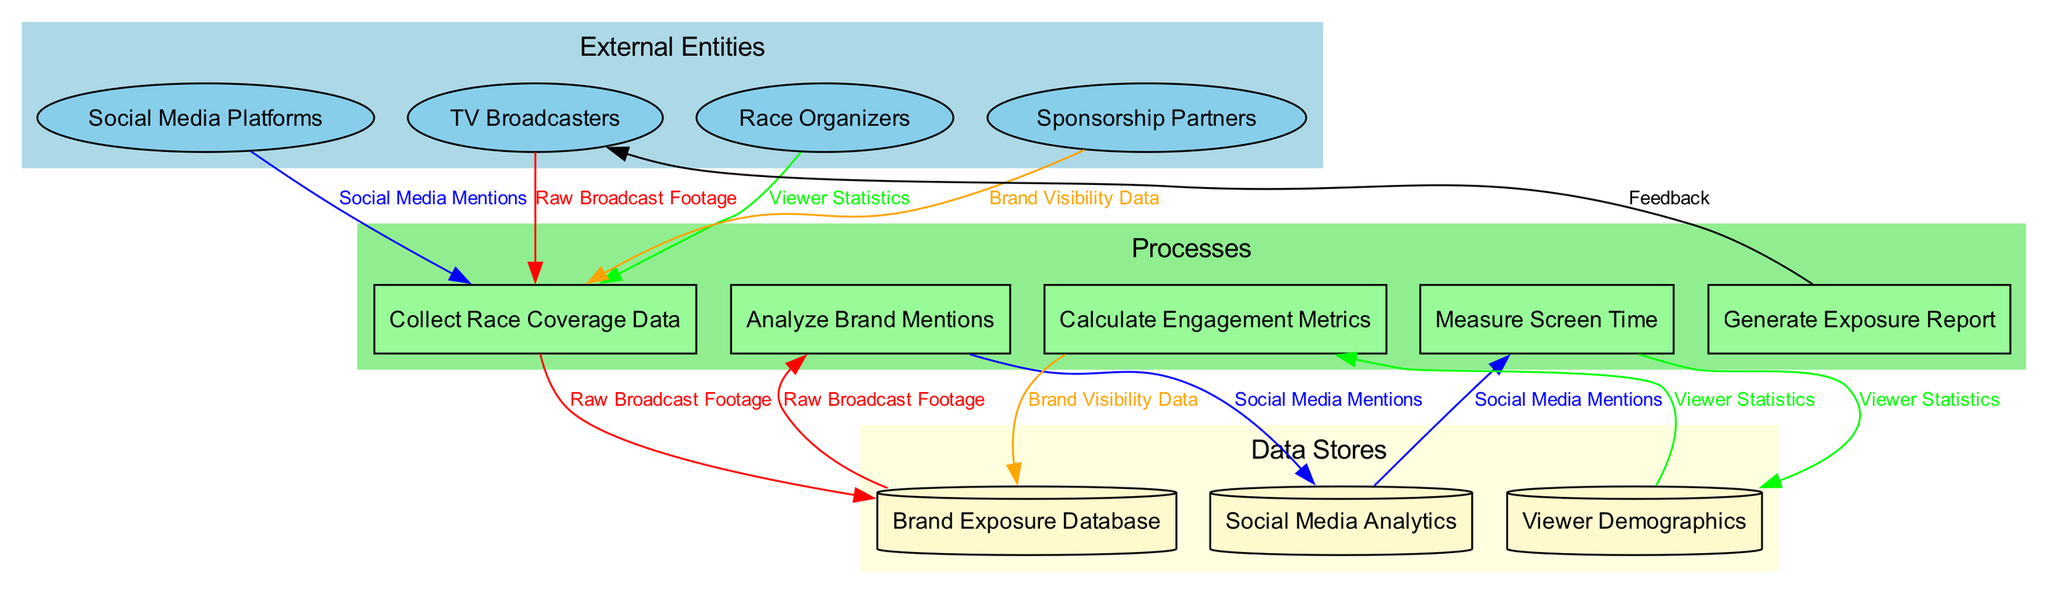What are the external entities presented in the diagram? The diagram identifies four external entities: TV Broadcasters, Social Media Platforms, Race Organizers, and Sponsorship Partners. Each entity is represented in the external entities section of the diagram.
Answer: TV Broadcasters, Social Media Platforms, Race Organizers, Sponsorship Partners How many processes are involved in the workflow? There are five distinct processes listed in the diagram: Collect Race Coverage Data, Analyze Brand Mentions, Measure Screen Time, Calculate Engagement Metrics, and Generate Exposure Report. This information is found in the processes section of the diagram.
Answer: Five Which data store is connected to the process "Analyze Brand Mentions"? The "Analyze Brand Mentions" process is connected to the "Social Media Analytics" data store. As per the flow connections in the diagram, each process is linked to a specific data store.
Answer: Social Media Analytics Which external entity receives the final feedback from the last process? The last process, "Generate Exposure Report," connects back to "TV Broadcasters," which indicates that this external entity receives the final feedback in the workflow. This flow is shown in the feedback connection from the last process back to the first external entity.
Answer: TV Broadcasters What type of data flows into the "Calculate Engagement Metrics" process? The "Calculate Engagement Metrics" process receives data from the "Brand Visibility Data" from the preceding data store. The data flows are indicated by the arrows that connect the data stores to the respective processes.
Answer: Brand Visibility Data How many data flows are depicted in the diagram? There are seven data flows illustrated in the diagram including: Raw Broadcast Footage, Social Media Mentions, Viewer Statistics, Brand Visibility Data, Engagement Scores, ROI Metrics, and Exposure Summary. This total can be counted from the data flows section of the diagram.
Answer: Seven What is the purpose of the "Generate Exposure Report" process? The purpose of the "Generate Exposure Report" process is to summarize the exposure metrics derived from previous analysis and measure effectiveness, which is evident from how it fits into the overall workflow for post-race analytics.
Answer: Summarize exposure metrics Which data store is not directly connected to the "Collect Race Coverage Data" process? The "Viewer Demographics" data store is not directly connected to the "Collect Race Coverage Data" process, as this connection is not represented in the flow between processes and data stores.
Answer: Viewer Demographics 